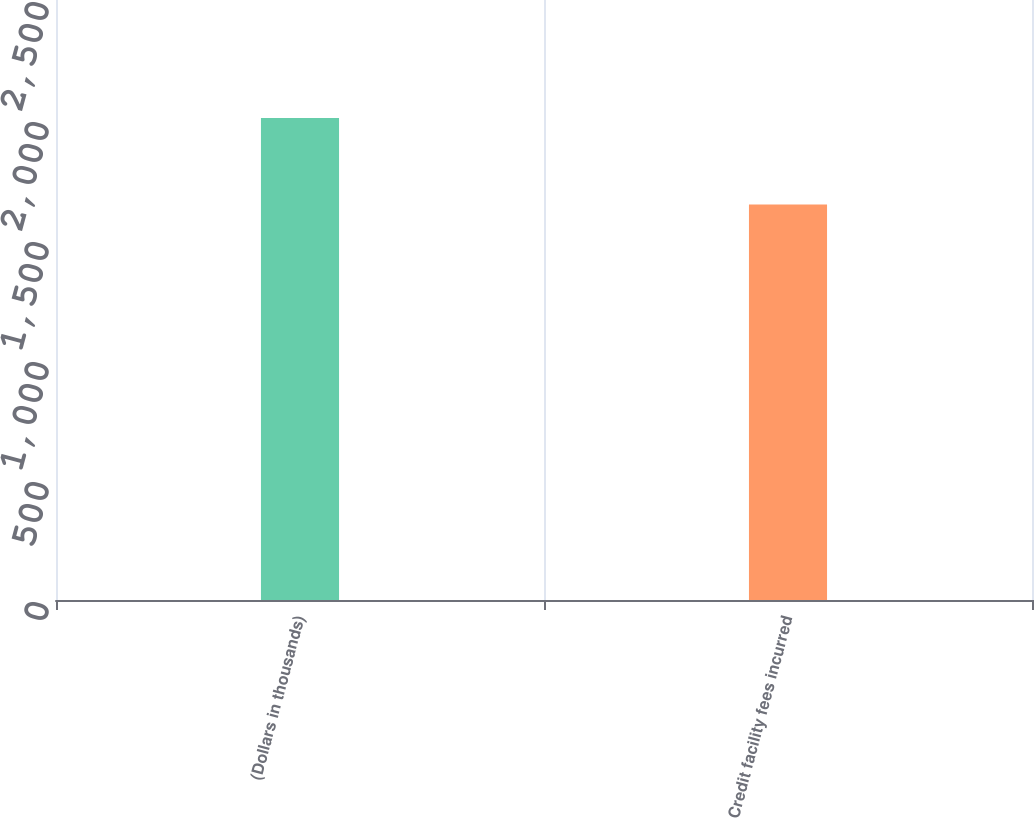Convert chart to OTSL. <chart><loc_0><loc_0><loc_500><loc_500><bar_chart><fcel>(Dollars in thousands)<fcel>Credit facility fees incurred<nl><fcel>2008<fcel>1648<nl></chart> 